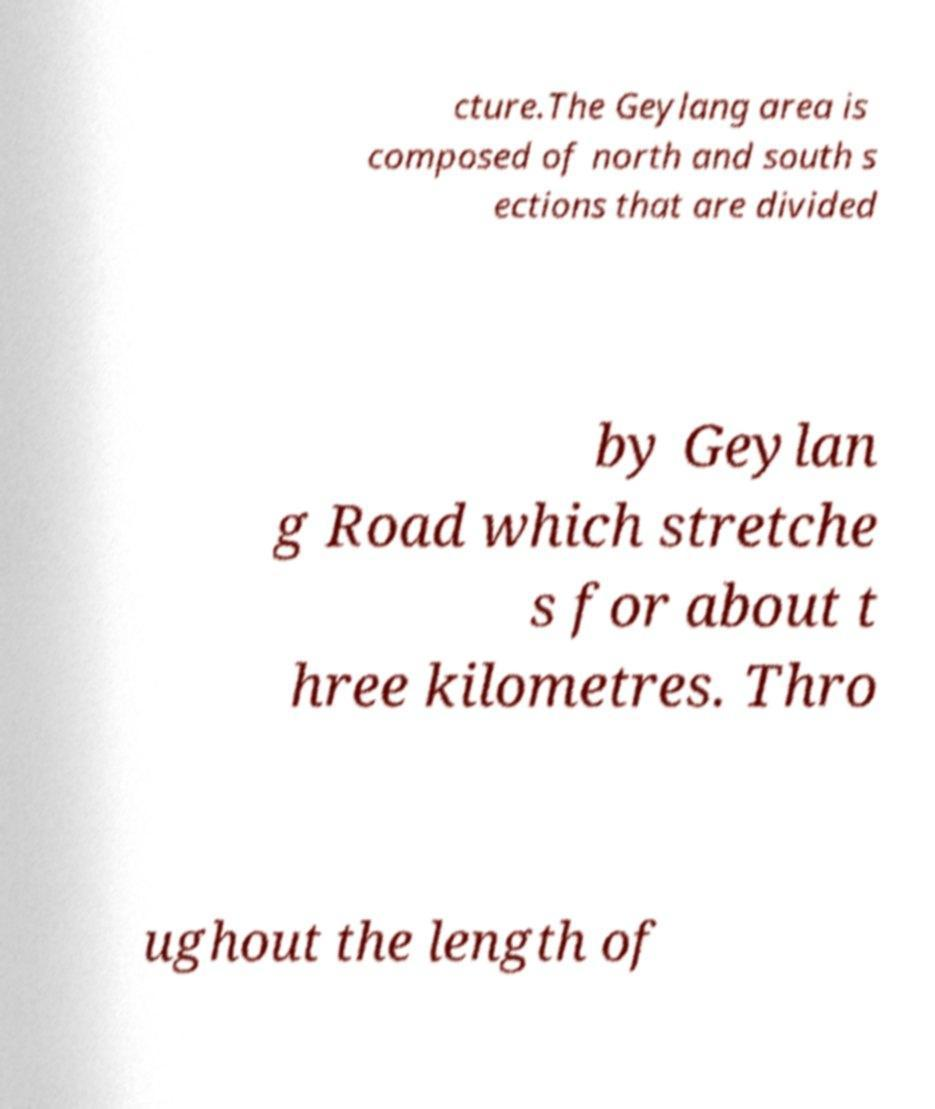For documentation purposes, I need the text within this image transcribed. Could you provide that? cture.The Geylang area is composed of north and south s ections that are divided by Geylan g Road which stretche s for about t hree kilometres. Thro ughout the length of 